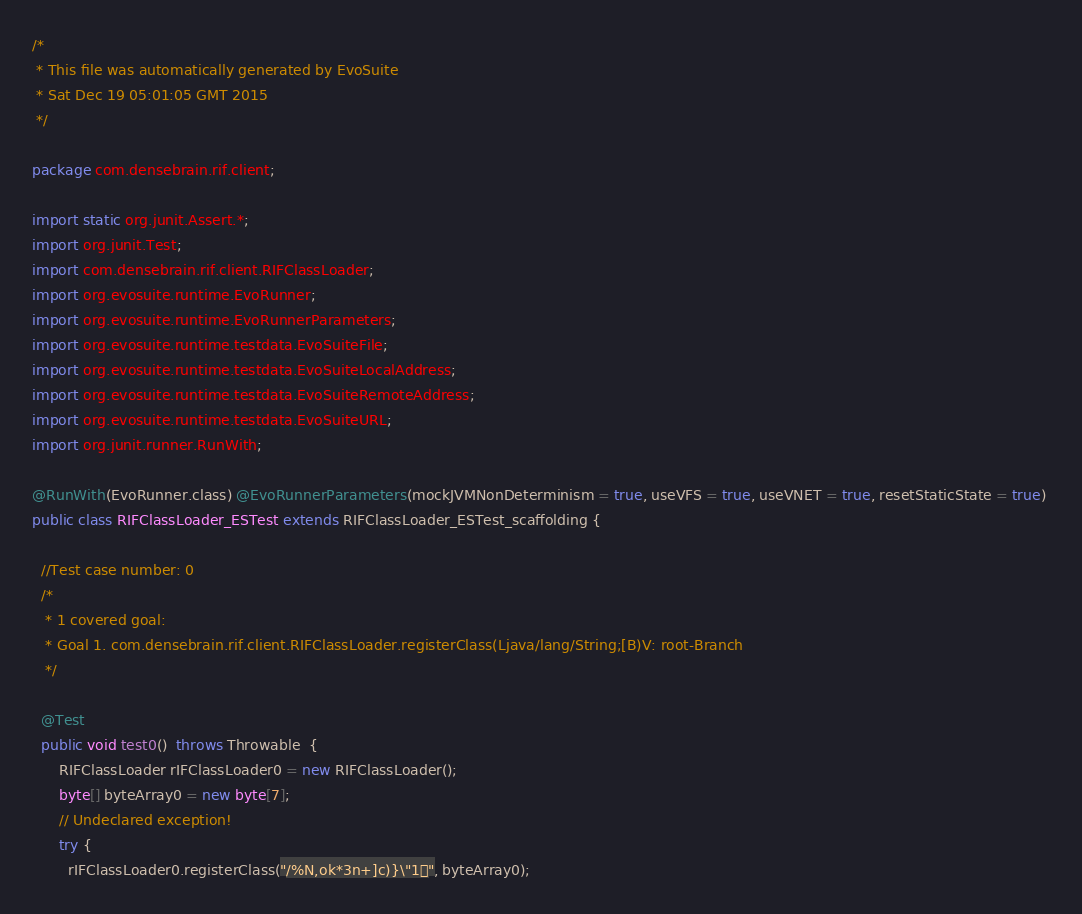Convert code to text. <code><loc_0><loc_0><loc_500><loc_500><_Java_>/*
 * This file was automatically generated by EvoSuite
 * Sat Dec 19 05:01:05 GMT 2015
 */

package com.densebrain.rif.client;

import static org.junit.Assert.*;
import org.junit.Test;
import com.densebrain.rif.client.RIFClassLoader;
import org.evosuite.runtime.EvoRunner;
import org.evosuite.runtime.EvoRunnerParameters;
import org.evosuite.runtime.testdata.EvoSuiteFile;
import org.evosuite.runtime.testdata.EvoSuiteLocalAddress;
import org.evosuite.runtime.testdata.EvoSuiteRemoteAddress;
import org.evosuite.runtime.testdata.EvoSuiteURL;
import org.junit.runner.RunWith;

@RunWith(EvoRunner.class) @EvoRunnerParameters(mockJVMNonDeterminism = true, useVFS = true, useVNET = true, resetStaticState = true) 
public class RIFClassLoader_ESTest extends RIFClassLoader_ESTest_scaffolding {

  //Test case number: 0
  /*
   * 1 covered goal:
   * Goal 1. com.densebrain.rif.client.RIFClassLoader.registerClass(Ljava/lang/String;[B)V: root-Branch
   */

  @Test
  public void test0()  throws Throwable  {
      RIFClassLoader rIFClassLoader0 = new RIFClassLoader();
      byte[] byteArray0 = new byte[7];
      // Undeclared exception!
      try {
        rIFClassLoader0.registerClass("/%N,ok*3n+]c)}\"1", byteArray0);</code> 